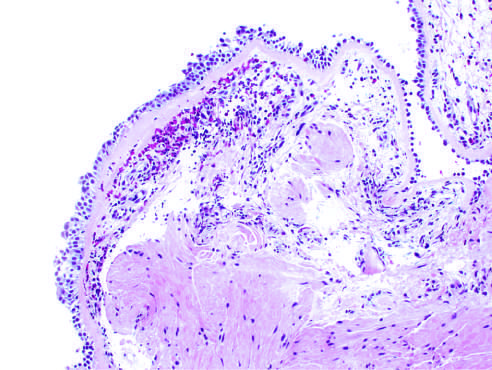does the bronchial biopsy specimen from an asthmatic patient show sub-basement membrane fibrosis, eosinophilic inflammation?
Answer the question using a single word or phrase. Yes 